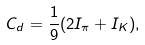Convert formula to latex. <formula><loc_0><loc_0><loc_500><loc_500>C _ { d } = \frac { 1 } { 9 } ( 2 I _ { \pi } + I _ { K } ) ,</formula> 